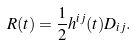Convert formula to latex. <formula><loc_0><loc_0><loc_500><loc_500>R ( t ) = \frac { 1 } { 2 } h ^ { i j } ( t ) D _ { i j } .</formula> 